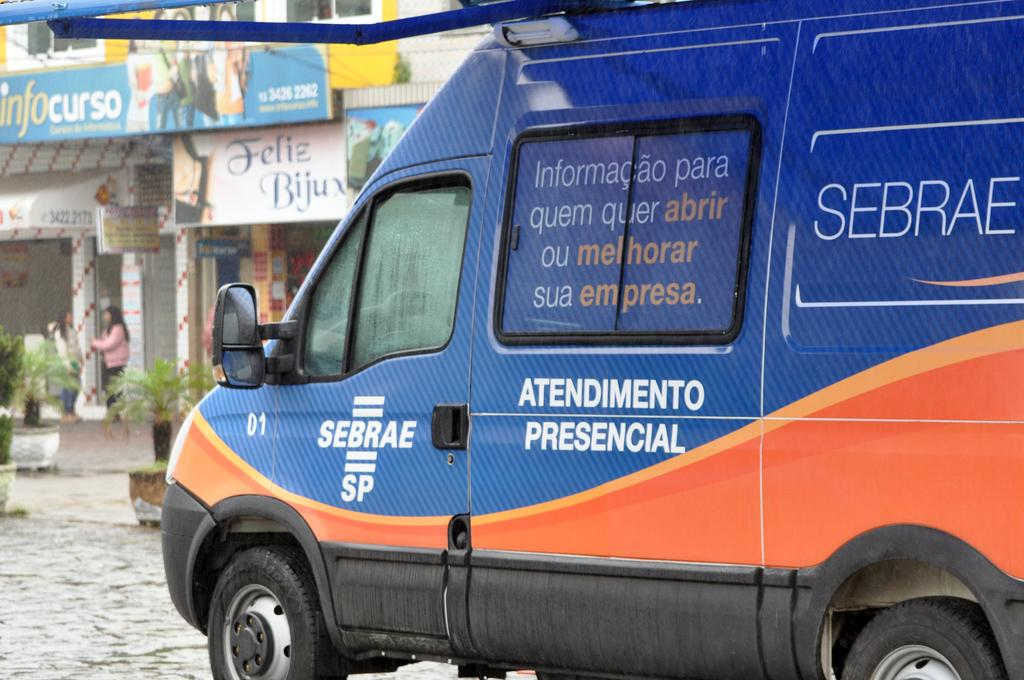<image>
Render a clear and concise summary of the photo. A red and orange van says Sebrae SP on the door. 